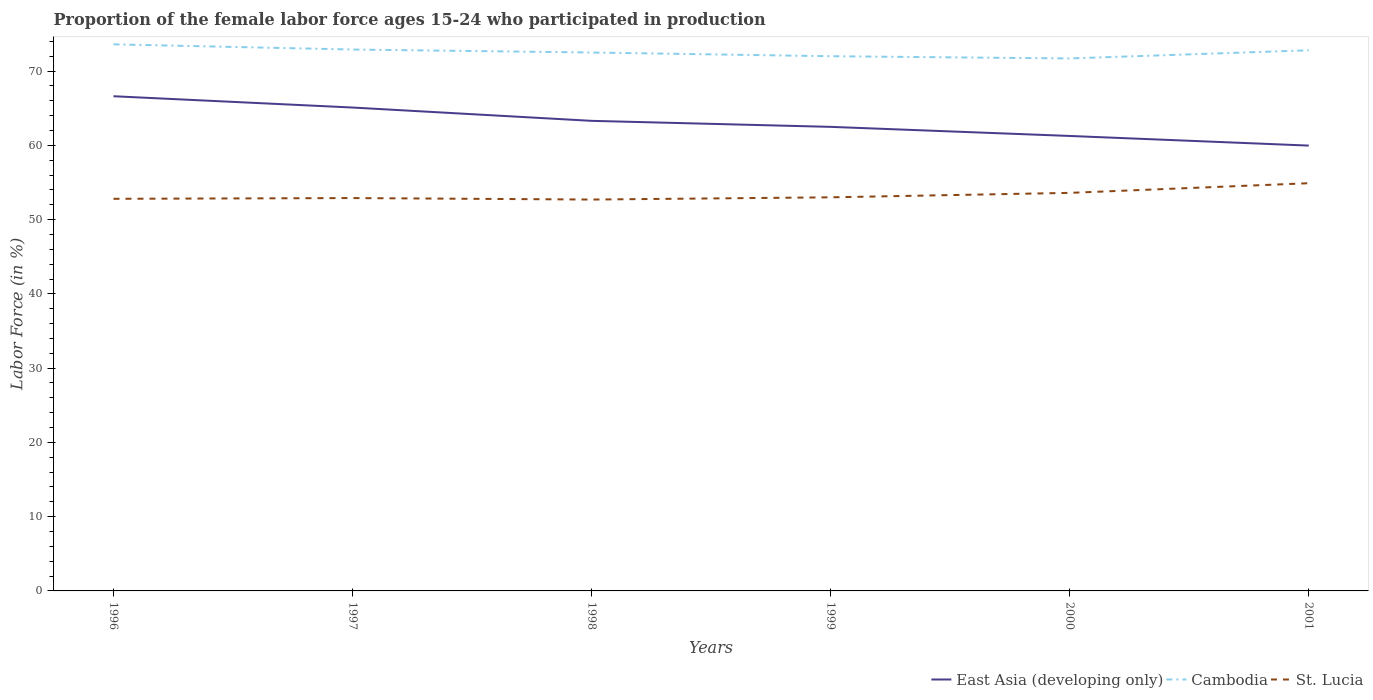How many different coloured lines are there?
Offer a terse response. 3. Across all years, what is the maximum proportion of the female labor force who participated in production in Cambodia?
Keep it short and to the point. 71.7. What is the total proportion of the female labor force who participated in production in St. Lucia in the graph?
Keep it short and to the point. -1.3. What is the difference between the highest and the second highest proportion of the female labor force who participated in production in Cambodia?
Provide a succinct answer. 1.9. What is the difference between the highest and the lowest proportion of the female labor force who participated in production in St. Lucia?
Your answer should be compact. 2. Is the proportion of the female labor force who participated in production in East Asia (developing only) strictly greater than the proportion of the female labor force who participated in production in Cambodia over the years?
Give a very brief answer. Yes. How many lines are there?
Your answer should be very brief. 3. How many years are there in the graph?
Keep it short and to the point. 6. What is the difference between two consecutive major ticks on the Y-axis?
Provide a succinct answer. 10. Are the values on the major ticks of Y-axis written in scientific E-notation?
Provide a short and direct response. No. Where does the legend appear in the graph?
Ensure brevity in your answer.  Bottom right. What is the title of the graph?
Ensure brevity in your answer.  Proportion of the female labor force ages 15-24 who participated in production. Does "Timor-Leste" appear as one of the legend labels in the graph?
Ensure brevity in your answer.  No. What is the Labor Force (in %) of East Asia (developing only) in 1996?
Offer a terse response. 66.61. What is the Labor Force (in %) in Cambodia in 1996?
Keep it short and to the point. 73.6. What is the Labor Force (in %) in St. Lucia in 1996?
Provide a succinct answer. 52.8. What is the Labor Force (in %) of East Asia (developing only) in 1997?
Make the answer very short. 65.09. What is the Labor Force (in %) in Cambodia in 1997?
Keep it short and to the point. 72.9. What is the Labor Force (in %) in St. Lucia in 1997?
Your answer should be very brief. 52.9. What is the Labor Force (in %) of East Asia (developing only) in 1998?
Your response must be concise. 63.3. What is the Labor Force (in %) in Cambodia in 1998?
Make the answer very short. 72.5. What is the Labor Force (in %) in St. Lucia in 1998?
Give a very brief answer. 52.7. What is the Labor Force (in %) of East Asia (developing only) in 1999?
Give a very brief answer. 62.49. What is the Labor Force (in %) in Cambodia in 1999?
Your answer should be very brief. 72. What is the Labor Force (in %) in East Asia (developing only) in 2000?
Ensure brevity in your answer.  61.26. What is the Labor Force (in %) of Cambodia in 2000?
Your response must be concise. 71.7. What is the Labor Force (in %) in St. Lucia in 2000?
Your response must be concise. 53.6. What is the Labor Force (in %) of East Asia (developing only) in 2001?
Your answer should be very brief. 59.97. What is the Labor Force (in %) in Cambodia in 2001?
Your response must be concise. 72.8. What is the Labor Force (in %) of St. Lucia in 2001?
Offer a terse response. 54.9. Across all years, what is the maximum Labor Force (in %) in East Asia (developing only)?
Make the answer very short. 66.61. Across all years, what is the maximum Labor Force (in %) of Cambodia?
Provide a short and direct response. 73.6. Across all years, what is the maximum Labor Force (in %) in St. Lucia?
Your answer should be very brief. 54.9. Across all years, what is the minimum Labor Force (in %) of East Asia (developing only)?
Ensure brevity in your answer.  59.97. Across all years, what is the minimum Labor Force (in %) in Cambodia?
Keep it short and to the point. 71.7. Across all years, what is the minimum Labor Force (in %) in St. Lucia?
Your answer should be very brief. 52.7. What is the total Labor Force (in %) in East Asia (developing only) in the graph?
Your answer should be compact. 378.72. What is the total Labor Force (in %) of Cambodia in the graph?
Offer a terse response. 435.5. What is the total Labor Force (in %) in St. Lucia in the graph?
Keep it short and to the point. 319.9. What is the difference between the Labor Force (in %) in East Asia (developing only) in 1996 and that in 1997?
Offer a very short reply. 1.52. What is the difference between the Labor Force (in %) in East Asia (developing only) in 1996 and that in 1998?
Provide a short and direct response. 3.31. What is the difference between the Labor Force (in %) of Cambodia in 1996 and that in 1998?
Your response must be concise. 1.1. What is the difference between the Labor Force (in %) of St. Lucia in 1996 and that in 1998?
Your response must be concise. 0.1. What is the difference between the Labor Force (in %) in East Asia (developing only) in 1996 and that in 1999?
Offer a very short reply. 4.12. What is the difference between the Labor Force (in %) of Cambodia in 1996 and that in 1999?
Your answer should be compact. 1.6. What is the difference between the Labor Force (in %) in St. Lucia in 1996 and that in 1999?
Ensure brevity in your answer.  -0.2. What is the difference between the Labor Force (in %) in East Asia (developing only) in 1996 and that in 2000?
Offer a very short reply. 5.35. What is the difference between the Labor Force (in %) in Cambodia in 1996 and that in 2000?
Keep it short and to the point. 1.9. What is the difference between the Labor Force (in %) in St. Lucia in 1996 and that in 2000?
Make the answer very short. -0.8. What is the difference between the Labor Force (in %) in East Asia (developing only) in 1996 and that in 2001?
Your response must be concise. 6.65. What is the difference between the Labor Force (in %) of East Asia (developing only) in 1997 and that in 1998?
Keep it short and to the point. 1.79. What is the difference between the Labor Force (in %) in Cambodia in 1997 and that in 1998?
Your answer should be very brief. 0.4. What is the difference between the Labor Force (in %) of St. Lucia in 1997 and that in 1998?
Make the answer very short. 0.2. What is the difference between the Labor Force (in %) in East Asia (developing only) in 1997 and that in 1999?
Keep it short and to the point. 2.6. What is the difference between the Labor Force (in %) in Cambodia in 1997 and that in 1999?
Ensure brevity in your answer.  0.9. What is the difference between the Labor Force (in %) of St. Lucia in 1997 and that in 1999?
Offer a very short reply. -0.1. What is the difference between the Labor Force (in %) of East Asia (developing only) in 1997 and that in 2000?
Offer a very short reply. 3.83. What is the difference between the Labor Force (in %) in East Asia (developing only) in 1997 and that in 2001?
Your response must be concise. 5.13. What is the difference between the Labor Force (in %) in Cambodia in 1997 and that in 2001?
Keep it short and to the point. 0.1. What is the difference between the Labor Force (in %) in St. Lucia in 1997 and that in 2001?
Make the answer very short. -2. What is the difference between the Labor Force (in %) in East Asia (developing only) in 1998 and that in 1999?
Make the answer very short. 0.81. What is the difference between the Labor Force (in %) in East Asia (developing only) in 1998 and that in 2000?
Keep it short and to the point. 2.04. What is the difference between the Labor Force (in %) in St. Lucia in 1998 and that in 2000?
Keep it short and to the point. -0.9. What is the difference between the Labor Force (in %) in East Asia (developing only) in 1998 and that in 2001?
Your response must be concise. 3.33. What is the difference between the Labor Force (in %) in St. Lucia in 1998 and that in 2001?
Your response must be concise. -2.2. What is the difference between the Labor Force (in %) in East Asia (developing only) in 1999 and that in 2000?
Ensure brevity in your answer.  1.23. What is the difference between the Labor Force (in %) in St. Lucia in 1999 and that in 2000?
Provide a short and direct response. -0.6. What is the difference between the Labor Force (in %) of East Asia (developing only) in 1999 and that in 2001?
Make the answer very short. 2.52. What is the difference between the Labor Force (in %) of Cambodia in 1999 and that in 2001?
Provide a succinct answer. -0.8. What is the difference between the Labor Force (in %) of East Asia (developing only) in 2000 and that in 2001?
Offer a terse response. 1.3. What is the difference between the Labor Force (in %) in Cambodia in 2000 and that in 2001?
Keep it short and to the point. -1.1. What is the difference between the Labor Force (in %) of St. Lucia in 2000 and that in 2001?
Your answer should be compact. -1.3. What is the difference between the Labor Force (in %) of East Asia (developing only) in 1996 and the Labor Force (in %) of Cambodia in 1997?
Offer a terse response. -6.29. What is the difference between the Labor Force (in %) in East Asia (developing only) in 1996 and the Labor Force (in %) in St. Lucia in 1997?
Give a very brief answer. 13.71. What is the difference between the Labor Force (in %) in Cambodia in 1996 and the Labor Force (in %) in St. Lucia in 1997?
Ensure brevity in your answer.  20.7. What is the difference between the Labor Force (in %) of East Asia (developing only) in 1996 and the Labor Force (in %) of Cambodia in 1998?
Give a very brief answer. -5.89. What is the difference between the Labor Force (in %) in East Asia (developing only) in 1996 and the Labor Force (in %) in St. Lucia in 1998?
Make the answer very short. 13.91. What is the difference between the Labor Force (in %) in Cambodia in 1996 and the Labor Force (in %) in St. Lucia in 1998?
Your answer should be very brief. 20.9. What is the difference between the Labor Force (in %) in East Asia (developing only) in 1996 and the Labor Force (in %) in Cambodia in 1999?
Your answer should be compact. -5.39. What is the difference between the Labor Force (in %) of East Asia (developing only) in 1996 and the Labor Force (in %) of St. Lucia in 1999?
Ensure brevity in your answer.  13.61. What is the difference between the Labor Force (in %) of Cambodia in 1996 and the Labor Force (in %) of St. Lucia in 1999?
Your answer should be compact. 20.6. What is the difference between the Labor Force (in %) in East Asia (developing only) in 1996 and the Labor Force (in %) in Cambodia in 2000?
Make the answer very short. -5.09. What is the difference between the Labor Force (in %) of East Asia (developing only) in 1996 and the Labor Force (in %) of St. Lucia in 2000?
Make the answer very short. 13.01. What is the difference between the Labor Force (in %) in Cambodia in 1996 and the Labor Force (in %) in St. Lucia in 2000?
Provide a short and direct response. 20. What is the difference between the Labor Force (in %) of East Asia (developing only) in 1996 and the Labor Force (in %) of Cambodia in 2001?
Give a very brief answer. -6.19. What is the difference between the Labor Force (in %) in East Asia (developing only) in 1996 and the Labor Force (in %) in St. Lucia in 2001?
Give a very brief answer. 11.71. What is the difference between the Labor Force (in %) in East Asia (developing only) in 1997 and the Labor Force (in %) in Cambodia in 1998?
Make the answer very short. -7.41. What is the difference between the Labor Force (in %) in East Asia (developing only) in 1997 and the Labor Force (in %) in St. Lucia in 1998?
Give a very brief answer. 12.39. What is the difference between the Labor Force (in %) of Cambodia in 1997 and the Labor Force (in %) of St. Lucia in 1998?
Provide a succinct answer. 20.2. What is the difference between the Labor Force (in %) of East Asia (developing only) in 1997 and the Labor Force (in %) of Cambodia in 1999?
Give a very brief answer. -6.91. What is the difference between the Labor Force (in %) in East Asia (developing only) in 1997 and the Labor Force (in %) in St. Lucia in 1999?
Offer a very short reply. 12.09. What is the difference between the Labor Force (in %) of East Asia (developing only) in 1997 and the Labor Force (in %) of Cambodia in 2000?
Your answer should be compact. -6.61. What is the difference between the Labor Force (in %) in East Asia (developing only) in 1997 and the Labor Force (in %) in St. Lucia in 2000?
Your answer should be compact. 11.49. What is the difference between the Labor Force (in %) in Cambodia in 1997 and the Labor Force (in %) in St. Lucia in 2000?
Offer a very short reply. 19.3. What is the difference between the Labor Force (in %) of East Asia (developing only) in 1997 and the Labor Force (in %) of Cambodia in 2001?
Offer a terse response. -7.71. What is the difference between the Labor Force (in %) in East Asia (developing only) in 1997 and the Labor Force (in %) in St. Lucia in 2001?
Keep it short and to the point. 10.19. What is the difference between the Labor Force (in %) in Cambodia in 1997 and the Labor Force (in %) in St. Lucia in 2001?
Give a very brief answer. 18. What is the difference between the Labor Force (in %) in East Asia (developing only) in 1998 and the Labor Force (in %) in Cambodia in 1999?
Give a very brief answer. -8.7. What is the difference between the Labor Force (in %) of East Asia (developing only) in 1998 and the Labor Force (in %) of St. Lucia in 1999?
Offer a very short reply. 10.3. What is the difference between the Labor Force (in %) of East Asia (developing only) in 1998 and the Labor Force (in %) of Cambodia in 2000?
Provide a succinct answer. -8.4. What is the difference between the Labor Force (in %) in East Asia (developing only) in 1998 and the Labor Force (in %) in St. Lucia in 2000?
Offer a terse response. 9.7. What is the difference between the Labor Force (in %) of Cambodia in 1998 and the Labor Force (in %) of St. Lucia in 2000?
Your response must be concise. 18.9. What is the difference between the Labor Force (in %) of East Asia (developing only) in 1998 and the Labor Force (in %) of Cambodia in 2001?
Your response must be concise. -9.5. What is the difference between the Labor Force (in %) of East Asia (developing only) in 1998 and the Labor Force (in %) of St. Lucia in 2001?
Keep it short and to the point. 8.4. What is the difference between the Labor Force (in %) in East Asia (developing only) in 1999 and the Labor Force (in %) in Cambodia in 2000?
Provide a short and direct response. -9.21. What is the difference between the Labor Force (in %) of East Asia (developing only) in 1999 and the Labor Force (in %) of St. Lucia in 2000?
Your answer should be compact. 8.89. What is the difference between the Labor Force (in %) in East Asia (developing only) in 1999 and the Labor Force (in %) in Cambodia in 2001?
Keep it short and to the point. -10.31. What is the difference between the Labor Force (in %) in East Asia (developing only) in 1999 and the Labor Force (in %) in St. Lucia in 2001?
Provide a short and direct response. 7.59. What is the difference between the Labor Force (in %) of Cambodia in 1999 and the Labor Force (in %) of St. Lucia in 2001?
Your answer should be compact. 17.1. What is the difference between the Labor Force (in %) in East Asia (developing only) in 2000 and the Labor Force (in %) in Cambodia in 2001?
Ensure brevity in your answer.  -11.54. What is the difference between the Labor Force (in %) in East Asia (developing only) in 2000 and the Labor Force (in %) in St. Lucia in 2001?
Your response must be concise. 6.36. What is the average Labor Force (in %) in East Asia (developing only) per year?
Keep it short and to the point. 63.12. What is the average Labor Force (in %) of Cambodia per year?
Make the answer very short. 72.58. What is the average Labor Force (in %) in St. Lucia per year?
Provide a short and direct response. 53.32. In the year 1996, what is the difference between the Labor Force (in %) of East Asia (developing only) and Labor Force (in %) of Cambodia?
Your answer should be compact. -6.99. In the year 1996, what is the difference between the Labor Force (in %) in East Asia (developing only) and Labor Force (in %) in St. Lucia?
Give a very brief answer. 13.81. In the year 1996, what is the difference between the Labor Force (in %) in Cambodia and Labor Force (in %) in St. Lucia?
Provide a short and direct response. 20.8. In the year 1997, what is the difference between the Labor Force (in %) of East Asia (developing only) and Labor Force (in %) of Cambodia?
Your answer should be compact. -7.81. In the year 1997, what is the difference between the Labor Force (in %) in East Asia (developing only) and Labor Force (in %) in St. Lucia?
Make the answer very short. 12.19. In the year 1997, what is the difference between the Labor Force (in %) of Cambodia and Labor Force (in %) of St. Lucia?
Your response must be concise. 20. In the year 1998, what is the difference between the Labor Force (in %) in East Asia (developing only) and Labor Force (in %) in Cambodia?
Ensure brevity in your answer.  -9.2. In the year 1998, what is the difference between the Labor Force (in %) in East Asia (developing only) and Labor Force (in %) in St. Lucia?
Offer a terse response. 10.6. In the year 1998, what is the difference between the Labor Force (in %) of Cambodia and Labor Force (in %) of St. Lucia?
Make the answer very short. 19.8. In the year 1999, what is the difference between the Labor Force (in %) in East Asia (developing only) and Labor Force (in %) in Cambodia?
Your answer should be very brief. -9.51. In the year 1999, what is the difference between the Labor Force (in %) of East Asia (developing only) and Labor Force (in %) of St. Lucia?
Your response must be concise. 9.49. In the year 2000, what is the difference between the Labor Force (in %) of East Asia (developing only) and Labor Force (in %) of Cambodia?
Offer a very short reply. -10.44. In the year 2000, what is the difference between the Labor Force (in %) in East Asia (developing only) and Labor Force (in %) in St. Lucia?
Provide a short and direct response. 7.66. In the year 2001, what is the difference between the Labor Force (in %) in East Asia (developing only) and Labor Force (in %) in Cambodia?
Provide a succinct answer. -12.83. In the year 2001, what is the difference between the Labor Force (in %) in East Asia (developing only) and Labor Force (in %) in St. Lucia?
Your response must be concise. 5.07. In the year 2001, what is the difference between the Labor Force (in %) of Cambodia and Labor Force (in %) of St. Lucia?
Give a very brief answer. 17.9. What is the ratio of the Labor Force (in %) in East Asia (developing only) in 1996 to that in 1997?
Provide a short and direct response. 1.02. What is the ratio of the Labor Force (in %) in Cambodia in 1996 to that in 1997?
Keep it short and to the point. 1.01. What is the ratio of the Labor Force (in %) in St. Lucia in 1996 to that in 1997?
Provide a short and direct response. 1. What is the ratio of the Labor Force (in %) of East Asia (developing only) in 1996 to that in 1998?
Your answer should be compact. 1.05. What is the ratio of the Labor Force (in %) of Cambodia in 1996 to that in 1998?
Your response must be concise. 1.02. What is the ratio of the Labor Force (in %) of East Asia (developing only) in 1996 to that in 1999?
Your answer should be compact. 1.07. What is the ratio of the Labor Force (in %) in Cambodia in 1996 to that in 1999?
Your response must be concise. 1.02. What is the ratio of the Labor Force (in %) in East Asia (developing only) in 1996 to that in 2000?
Provide a succinct answer. 1.09. What is the ratio of the Labor Force (in %) in Cambodia in 1996 to that in 2000?
Your response must be concise. 1.03. What is the ratio of the Labor Force (in %) of St. Lucia in 1996 to that in 2000?
Ensure brevity in your answer.  0.99. What is the ratio of the Labor Force (in %) of East Asia (developing only) in 1996 to that in 2001?
Offer a very short reply. 1.11. What is the ratio of the Labor Force (in %) of Cambodia in 1996 to that in 2001?
Offer a very short reply. 1.01. What is the ratio of the Labor Force (in %) in St. Lucia in 1996 to that in 2001?
Offer a very short reply. 0.96. What is the ratio of the Labor Force (in %) of East Asia (developing only) in 1997 to that in 1998?
Keep it short and to the point. 1.03. What is the ratio of the Labor Force (in %) in Cambodia in 1997 to that in 1998?
Make the answer very short. 1.01. What is the ratio of the Labor Force (in %) of East Asia (developing only) in 1997 to that in 1999?
Give a very brief answer. 1.04. What is the ratio of the Labor Force (in %) in Cambodia in 1997 to that in 1999?
Your response must be concise. 1.01. What is the ratio of the Labor Force (in %) of St. Lucia in 1997 to that in 1999?
Ensure brevity in your answer.  1. What is the ratio of the Labor Force (in %) of Cambodia in 1997 to that in 2000?
Ensure brevity in your answer.  1.02. What is the ratio of the Labor Force (in %) in St. Lucia in 1997 to that in 2000?
Ensure brevity in your answer.  0.99. What is the ratio of the Labor Force (in %) of East Asia (developing only) in 1997 to that in 2001?
Make the answer very short. 1.09. What is the ratio of the Labor Force (in %) in Cambodia in 1997 to that in 2001?
Your answer should be compact. 1. What is the ratio of the Labor Force (in %) of St. Lucia in 1997 to that in 2001?
Make the answer very short. 0.96. What is the ratio of the Labor Force (in %) of Cambodia in 1998 to that in 1999?
Provide a succinct answer. 1.01. What is the ratio of the Labor Force (in %) of East Asia (developing only) in 1998 to that in 2000?
Your answer should be compact. 1.03. What is the ratio of the Labor Force (in %) of Cambodia in 1998 to that in 2000?
Provide a succinct answer. 1.01. What is the ratio of the Labor Force (in %) in St. Lucia in 1998 to that in 2000?
Your response must be concise. 0.98. What is the ratio of the Labor Force (in %) in East Asia (developing only) in 1998 to that in 2001?
Ensure brevity in your answer.  1.06. What is the ratio of the Labor Force (in %) in St. Lucia in 1998 to that in 2001?
Your answer should be very brief. 0.96. What is the ratio of the Labor Force (in %) in East Asia (developing only) in 1999 to that in 2000?
Provide a succinct answer. 1.02. What is the ratio of the Labor Force (in %) in East Asia (developing only) in 1999 to that in 2001?
Keep it short and to the point. 1.04. What is the ratio of the Labor Force (in %) of St. Lucia in 1999 to that in 2001?
Offer a terse response. 0.97. What is the ratio of the Labor Force (in %) of East Asia (developing only) in 2000 to that in 2001?
Give a very brief answer. 1.02. What is the ratio of the Labor Force (in %) in Cambodia in 2000 to that in 2001?
Your answer should be compact. 0.98. What is the ratio of the Labor Force (in %) of St. Lucia in 2000 to that in 2001?
Offer a terse response. 0.98. What is the difference between the highest and the second highest Labor Force (in %) of East Asia (developing only)?
Provide a short and direct response. 1.52. What is the difference between the highest and the second highest Labor Force (in %) of Cambodia?
Your answer should be compact. 0.7. What is the difference between the highest and the second highest Labor Force (in %) in St. Lucia?
Provide a short and direct response. 1.3. What is the difference between the highest and the lowest Labor Force (in %) in East Asia (developing only)?
Give a very brief answer. 6.65. What is the difference between the highest and the lowest Labor Force (in %) of St. Lucia?
Offer a terse response. 2.2. 